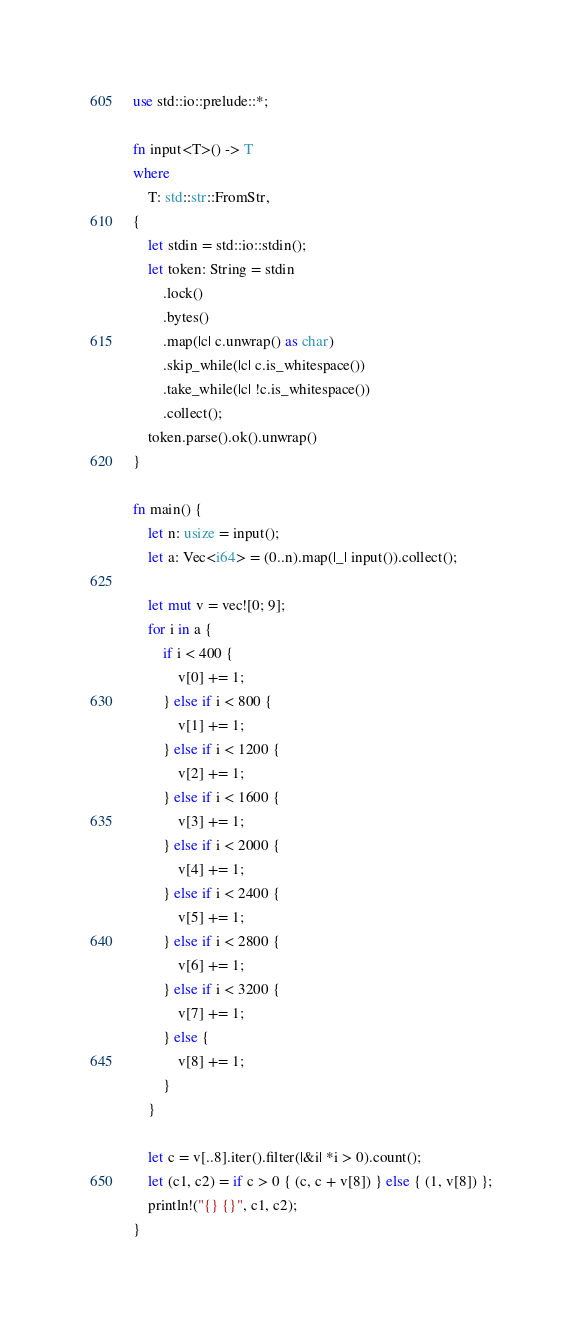<code> <loc_0><loc_0><loc_500><loc_500><_Rust_>use std::io::prelude::*;

fn input<T>() -> T
where
    T: std::str::FromStr,
{
    let stdin = std::io::stdin();
    let token: String = stdin
        .lock()
        .bytes()
        .map(|c| c.unwrap() as char)
        .skip_while(|c| c.is_whitespace())
        .take_while(|c| !c.is_whitespace())
        .collect();
    token.parse().ok().unwrap()
}

fn main() {
    let n: usize = input();
    let a: Vec<i64> = (0..n).map(|_| input()).collect();

    let mut v = vec![0; 9];
    for i in a {
        if i < 400 {
            v[0] += 1;
        } else if i < 800 {
            v[1] += 1;
        } else if i < 1200 {
            v[2] += 1;
        } else if i < 1600 {
            v[3] += 1;
        } else if i < 2000 {
            v[4] += 1;
        } else if i < 2400 {
            v[5] += 1;
        } else if i < 2800 {
            v[6] += 1;
        } else if i < 3200 {
            v[7] += 1;
        } else {
            v[8] += 1;
        }
    }

    let c = v[..8].iter().filter(|&i| *i > 0).count();
    let (c1, c2) = if c > 0 { (c, c + v[8]) } else { (1, v[8]) };
    println!("{} {}", c1, c2);
}
</code> 